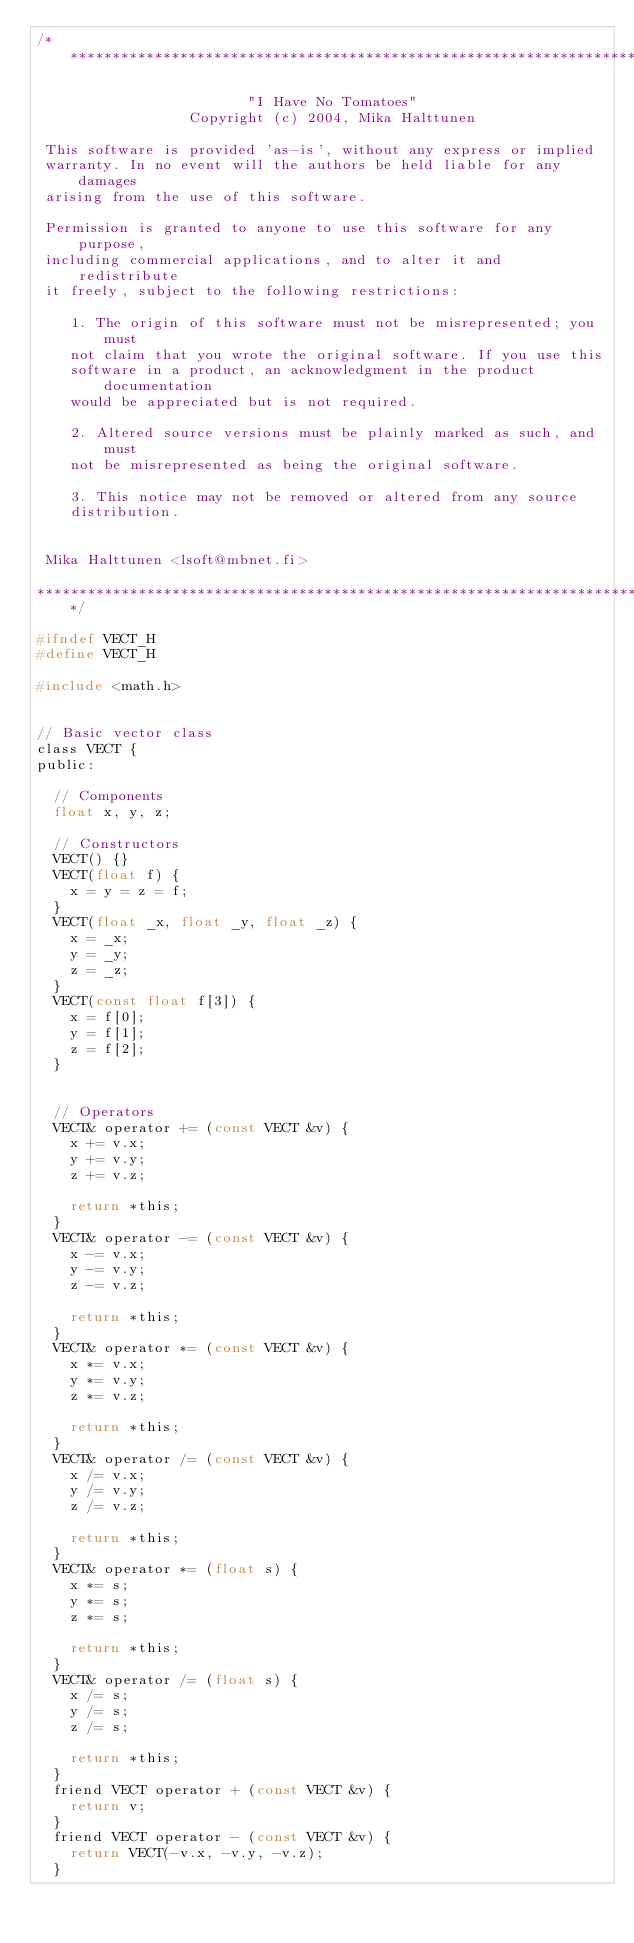Convert code to text. <code><loc_0><loc_0><loc_500><loc_500><_C_>/*************************************************************************

                         "I Have No Tomatoes"
                  Copyright (c) 2004, Mika Halttunen

 This software is provided 'as-is', without any express or implied
 warranty. In no event will the authors be held liable for any damages
 arising from the use of this software.

 Permission is granted to anyone to use this software for any purpose,
 including commercial applications, and to alter it and redistribute
 it freely, subject to the following restrictions:

    1. The origin of this software must not be misrepresented; you must
    not claim that you wrote the original software. If you use this
    software in a product, an acknowledgment in the product documentation
    would be appreciated but is not required.

    2. Altered source versions must be plainly marked as such, and must
    not be misrepresented as being the original software.

    3. This notice may not be removed or altered from any source
    distribution.


 Mika Halttunen <lsoft@mbnet.fi>

*************************************************************************/

#ifndef VECT_H
#define VECT_H

#include <math.h>


// Basic vector class
class VECT {
public:

	// Components
	float x, y, z;

	// Constructors
	VECT() {}
	VECT(float f) {
		x = y = z = f;
	}
	VECT(float _x, float _y, float _z) {
		x = _x;
		y = _y;
		z = _z;
	}
	VECT(const float f[3]) {
		x = f[0];
		y = f[1];
		z = f[2];
	}


	// Operators
	VECT& operator += (const VECT &v) {
		x += v.x;
		y += v.y;
		z += v.z;

		return *this;
	}
	VECT& operator -= (const VECT &v) {
		x -= v.x;
		y -= v.y;
		z -= v.z;

		return *this;
	}
	VECT& operator *= (const VECT &v) {
		x *= v.x;
		y *= v.y;
		z *= v.z;

		return *this;
	}
	VECT& operator /= (const VECT &v) {
		x /= v.x;
		y /= v.y;
		z /= v.z;

		return *this;
	}
	VECT& operator *= (float s) {
		x *= s;
		y *= s;
		z *= s;

		return *this;
	}
	VECT& operator /= (float s) {
		x /= s;
		y /= s;
		z /= s;

		return *this;
	}
	friend VECT operator + (const VECT &v) {
		return v;
	}
	friend VECT operator - (const VECT &v) {
		return VECT(-v.x, -v.y, -v.z);
	}</code> 